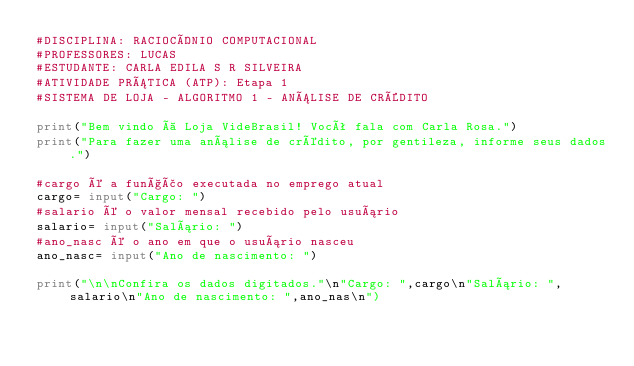Convert code to text. <code><loc_0><loc_0><loc_500><loc_500><_Python_>#DISCIPLINA: RACIOCÍNIO COMPUTACIONAL
#PROFESSORES: LUCAS 
#ESTUDANTE: CARLA EDILA S R SILVEIRA
#ATIVIDADE PRÁTICA (ATP): Etapa 1
#SISTEMA DE LOJA - ALGORITMO 1 - ANÁLISE DE CRÉDITO

print("Bem vindo à Loja VideBrasil! Você fala com Carla Rosa.")
print("Para fazer uma análise de crédito, por gentileza, informe seus dados.")

#cargo é a função executada no emprego atual
cargo= input("Cargo: ")
#salario é o valor mensal recebido pelo usuário
salario= input("Salário: ")
#ano_nasc é o ano em que o usuário nasceu
ano_nasc= input("Ano de nascimento: ")

print("\n\nConfira os dados digitados."\n"Cargo: ",cargo\n"Salário: ",salario\n"Ano de nascimento: ",ano_nas\n")





</code> 